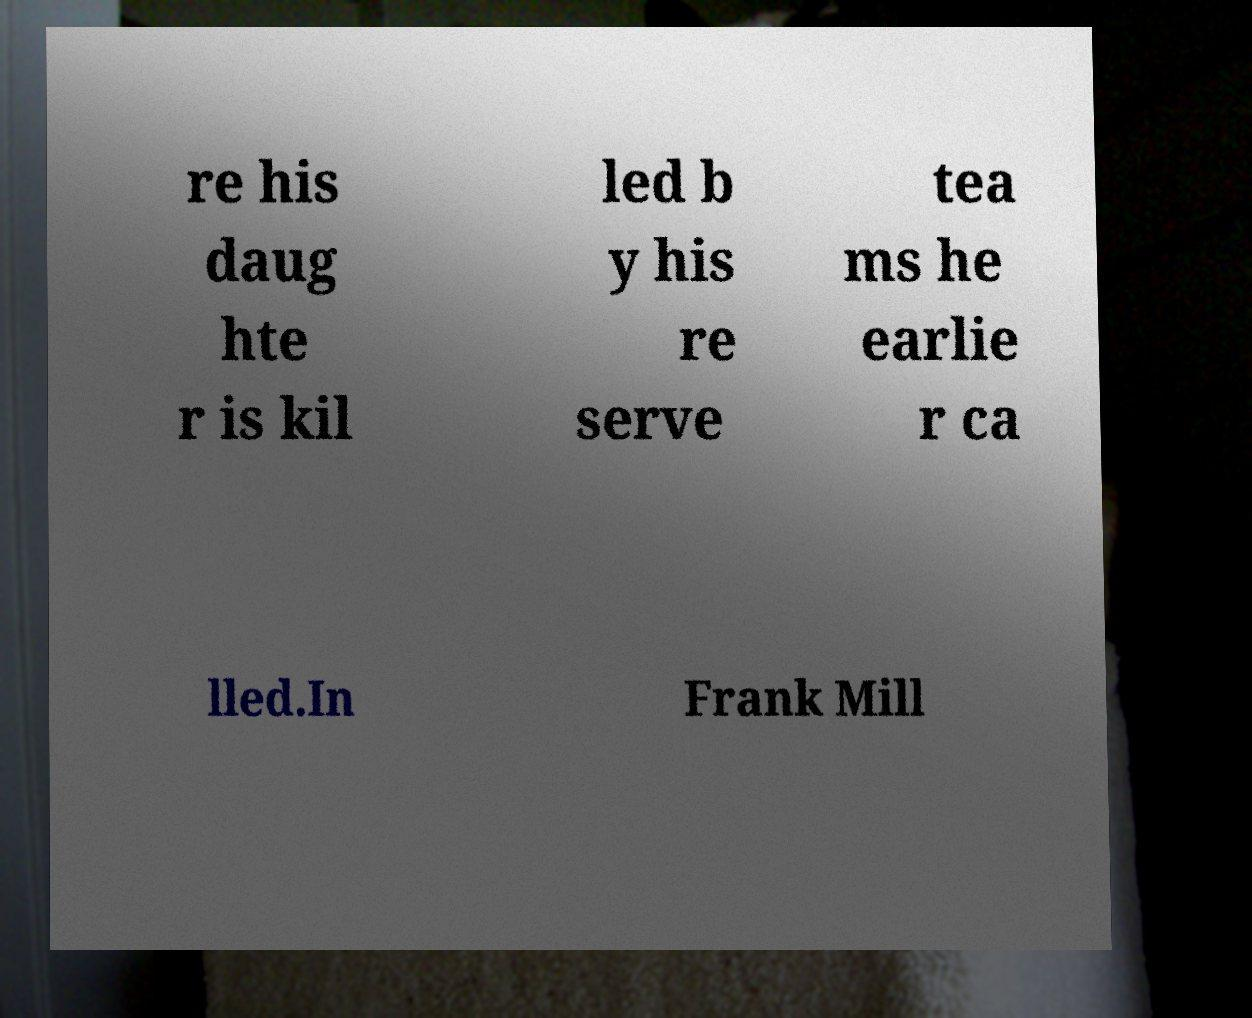Could you extract and type out the text from this image? re his daug hte r is kil led b y his re serve tea ms he earlie r ca lled.In Frank Mill 